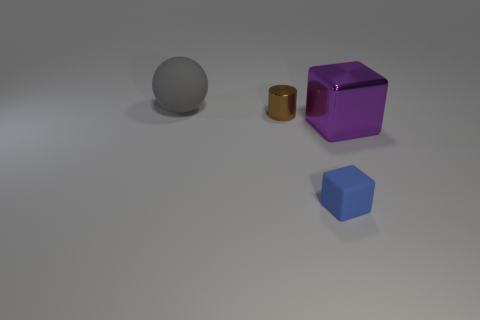Add 4 purple matte blocks. How many objects exist? 8 Subtract all cylinders. How many objects are left? 3 Add 4 big matte things. How many big matte things exist? 5 Subtract 0 blue cylinders. How many objects are left? 4 Subtract all tiny matte cubes. Subtract all brown metallic things. How many objects are left? 2 Add 4 purple cubes. How many purple cubes are left? 5 